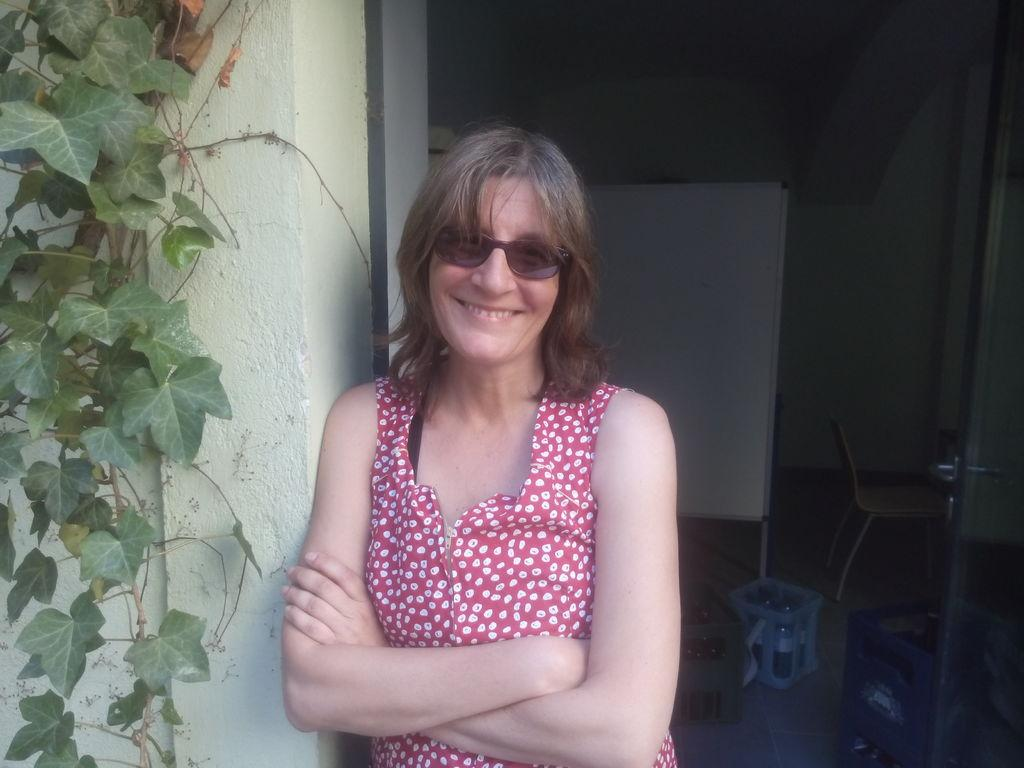What is the main subject of the image? There is a woman standing in the image. Where is the woman positioned in the image? The woman is standing at a wall. What can be seen on the left side of the image? There is a creeper on the left side of the image. What objects are visible in the background of the image? There is a chair, a board, and a wall in the background of the image. What type of stew is being prepared on the board in the image? There is no stew or any cooking activity present in the image. Can you tell me how many chickens are sitting on the chair in the image? There are no chickens present in the image; only a chair, a board, and a wall are visible in the background. 